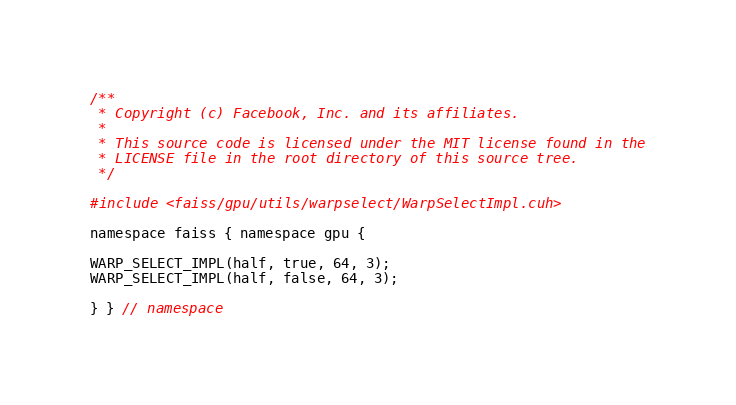<code> <loc_0><loc_0><loc_500><loc_500><_Cuda_>/**
 * Copyright (c) Facebook, Inc. and its affiliates.
 *
 * This source code is licensed under the MIT license found in the
 * LICENSE file in the root directory of this source tree.
 */

#include <faiss/gpu/utils/warpselect/WarpSelectImpl.cuh>

namespace faiss { namespace gpu {

WARP_SELECT_IMPL(half, true, 64, 3);
WARP_SELECT_IMPL(half, false, 64, 3);

} } // namespace
</code> 